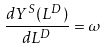Convert formula to latex. <formula><loc_0><loc_0><loc_500><loc_500>\frac { d Y ^ { S } ( L ^ { D } ) } { d L ^ { D } } = \omega</formula> 